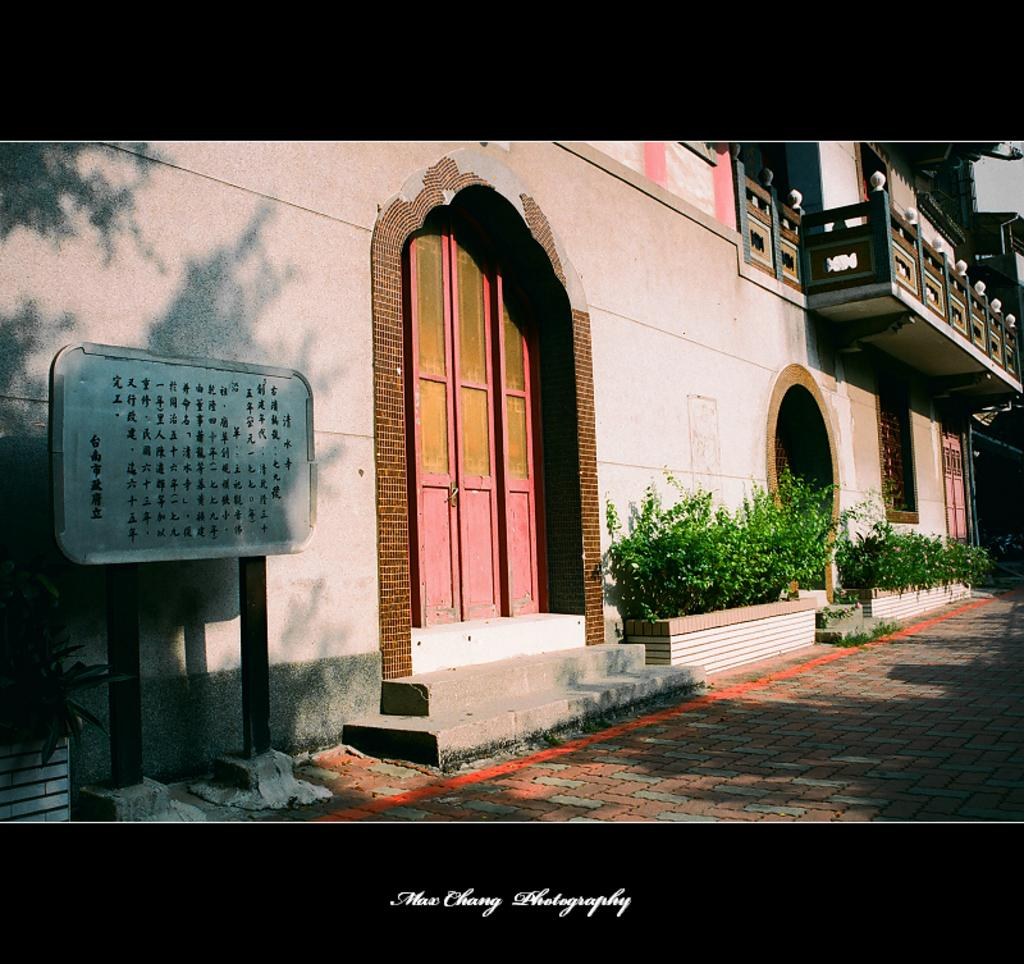What is the main subject of the image? The main subject of the image is a house. What features can be seen on the house? The house has doors and windows. What else is visible near the house? There are plants near the house. What is located on the left side of the image? There is a boat on the left side of the image. What is visible at the bottom of the image? There is a floor visible at the bottom of the image. What can be read at the bottom of the image? There is text present at the bottom of the image. What type of mint is being used to flavor the lunch in the image? There is no mention of lunch or mint in the image; it features a house, a boat, plants, and text. 